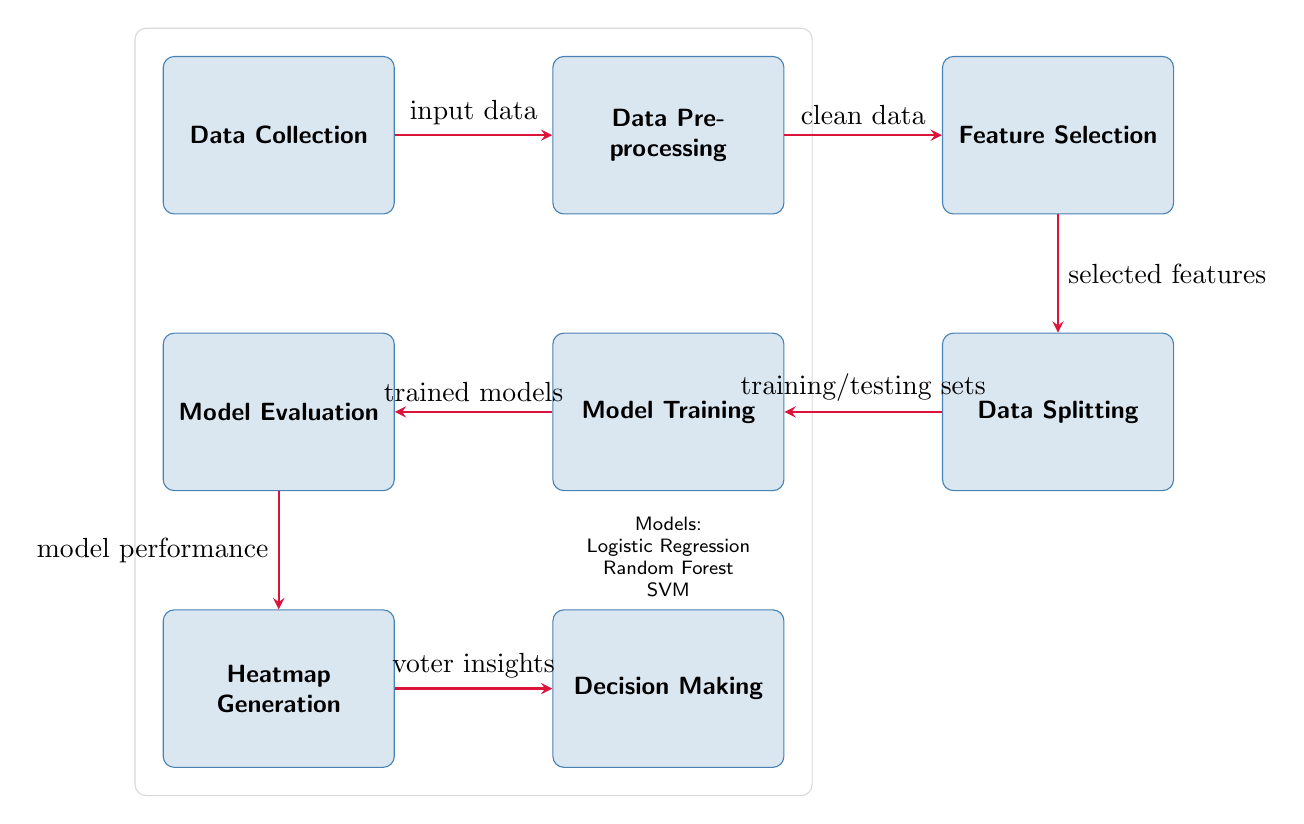What is the first step in the diagram? The diagram clearly shows that the first step is labeled as "Data Collection," which is the starting point of the process.
Answer: Data Collection How many models are mentioned in the diagram? The diagram lists three models below the "Model Training" node, which are "Logistic Regression," "Random Forest," and "SVM."
Answer: Three What operation follows "Feature Selection"? According to the diagram, the operation that follows "Feature Selection" is "Data Splitting," indicated by the directed arrow leading from "Feature Selection" to "Data Splitting."
Answer: Data Splitting What is generated after "Model Evaluation"? The diagram indicates that after "Model Evaluation," the next output is "Heatmap Generation," shown by the arrow from "Model Evaluation" to "Heatmap Generation."
Answer: Heatmap Generation How many nodes are involved in the process from "Data Collection" to "Decision Making"? There are six nodes included in this flow: "Data Collection," "Data Preprocessing," "Feature Selection," "Data Splitting," "Model Training," "Model Evaluation," "Heatmap Generation," and "Decision Making," so totaling eight nodes.
Answer: Eight Which node is associated with insights for decision-making? The diagram shows that "Heatmap Generation" directly leads to "Decision Making," implying it's associated with providing insights necessary for decision-making.
Answer: Heatmap Generation What does the arrow from "Data Preprocessing" indicate? The arrow from "Data Preprocessing" to "Feature Selection" signifies that clean data is the input required for feature selection to be carried out successfully.
Answer: Clean data What type of machine learning models are indicated in the "Model Training" node? The models listed under "Model Training" in the diagram include "Logistic Regression," "Random Forest," and "SVM," which are types of machine learning algorithms.
Answer: Logistic Regression, Random Forest, SVM What flows into "Model Evaluation"? The arrow leading into "Model Evaluation" specifies that "Trained models" are the input for evaluating how well the models perform in predicting voter alignment.
Answer: Trained models 